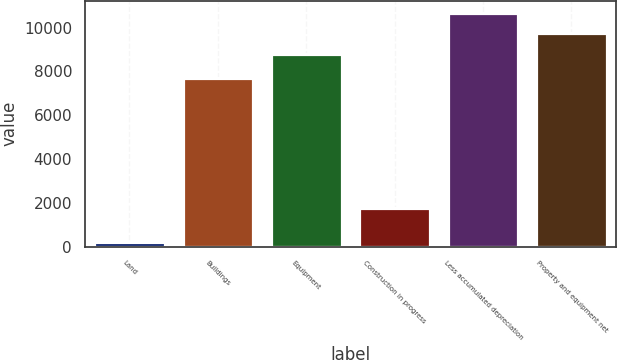Convert chart. <chart><loc_0><loc_0><loc_500><loc_500><bar_chart><fcel>Land<fcel>Buildings<fcel>Equipment<fcel>Construction in progress<fcel>Less accumulated depreciation<fcel>Property and equipment net<nl><fcel>193.1<fcel>7683.8<fcel>8817.4<fcel>1769.7<fcel>10687.7<fcel>9752.54<nl></chart> 